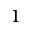Convert formula to latex. <formula><loc_0><loc_0><loc_500><loc_500>^ { 1 }</formula> 